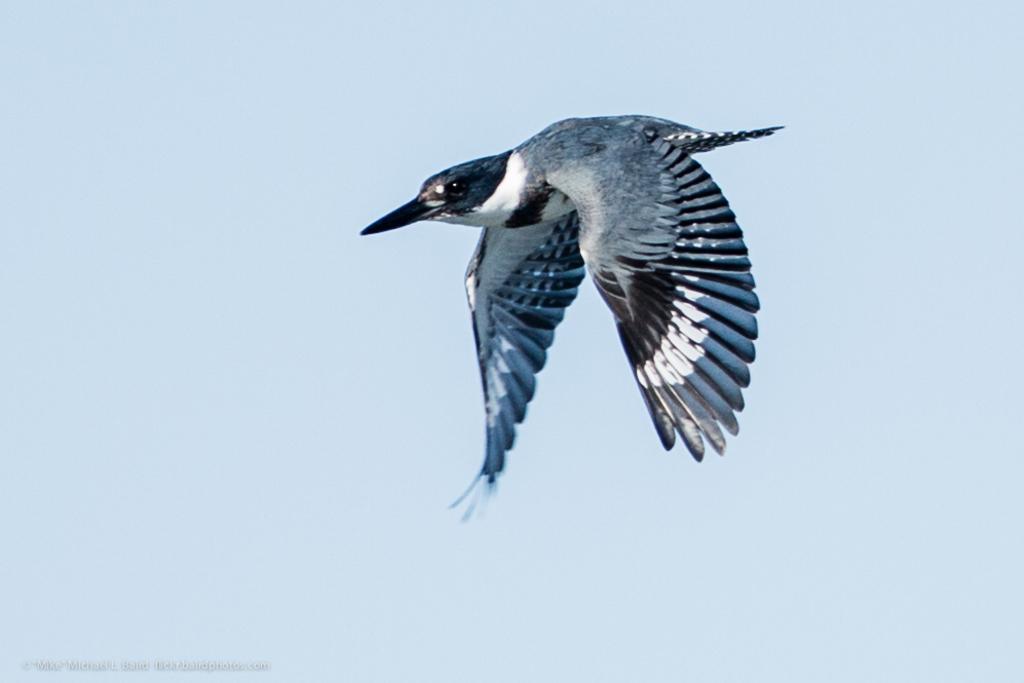How would you summarize this image in a sentence or two? In this picture I can see a bird flying and I can see sky and text at the bottom left corner of the picture. 